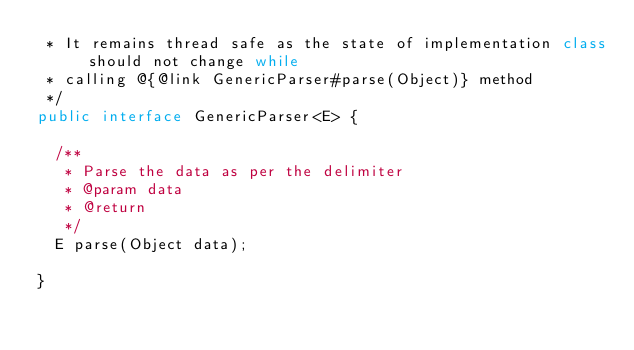<code> <loc_0><loc_0><loc_500><loc_500><_Java_> * It remains thread safe as the state of implementation class should not change while
 * calling @{@link GenericParser#parse(Object)} method
 */
public interface GenericParser<E> {

  /**
   * Parse the data as per the delimiter
   * @param data
   * @return
   */
  E parse(Object data);

}
</code> 